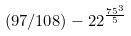Convert formula to latex. <formula><loc_0><loc_0><loc_500><loc_500>( 9 7 / 1 0 8 ) - 2 2 ^ { \frac { 7 5 ^ { 3 } } { 5 } }</formula> 